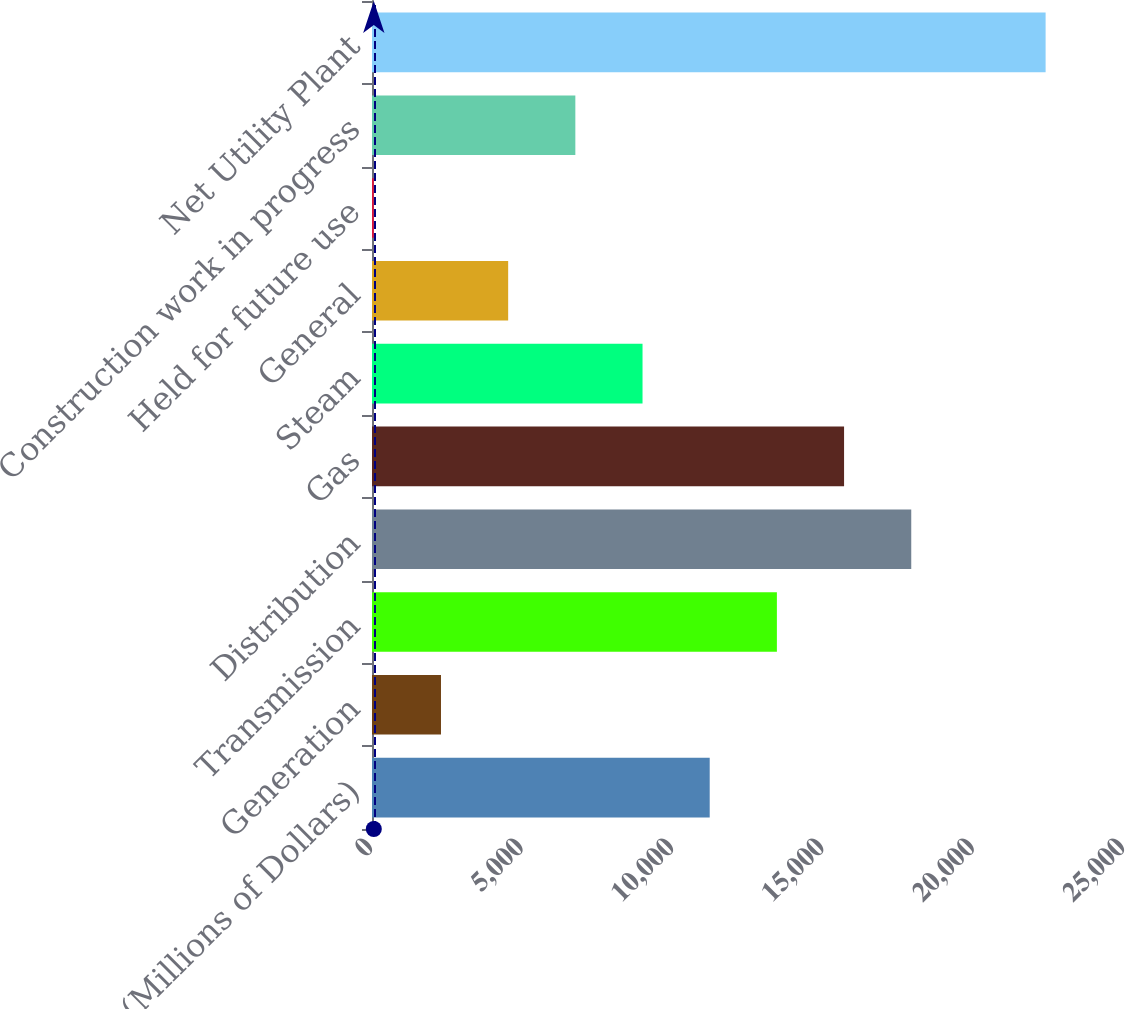Convert chart. <chart><loc_0><loc_0><loc_500><loc_500><bar_chart><fcel>(Millions of Dollars)<fcel>Generation<fcel>Transmission<fcel>Distribution<fcel>Gas<fcel>Steam<fcel>General<fcel>Held for future use<fcel>Construction work in progress<fcel>Net Utility Plant<nl><fcel>11227<fcel>2293.4<fcel>13460.4<fcel>17927.2<fcel>15693.8<fcel>8993.6<fcel>4526.8<fcel>60<fcel>6760.2<fcel>22394<nl></chart> 